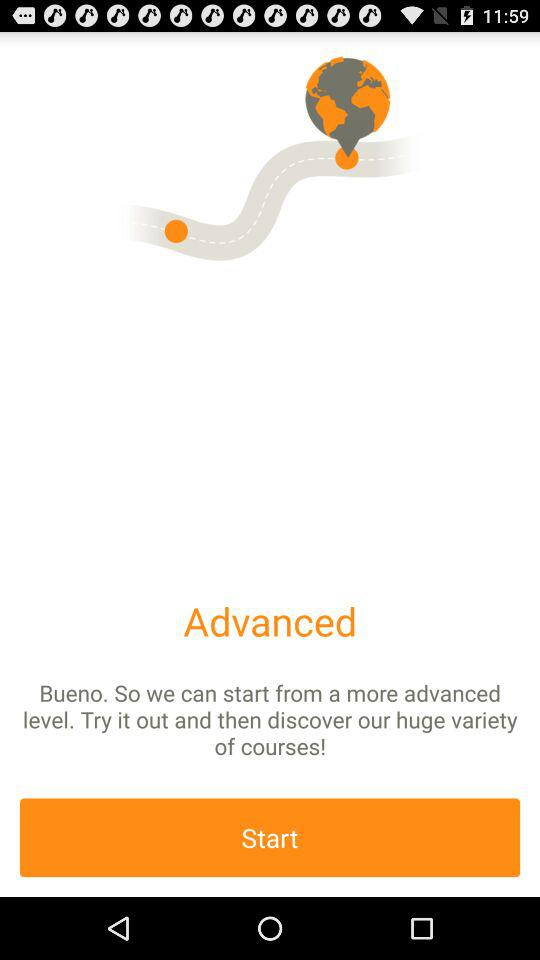When did the course start?
When the provided information is insufficient, respond with <no answer>. <no answer> 